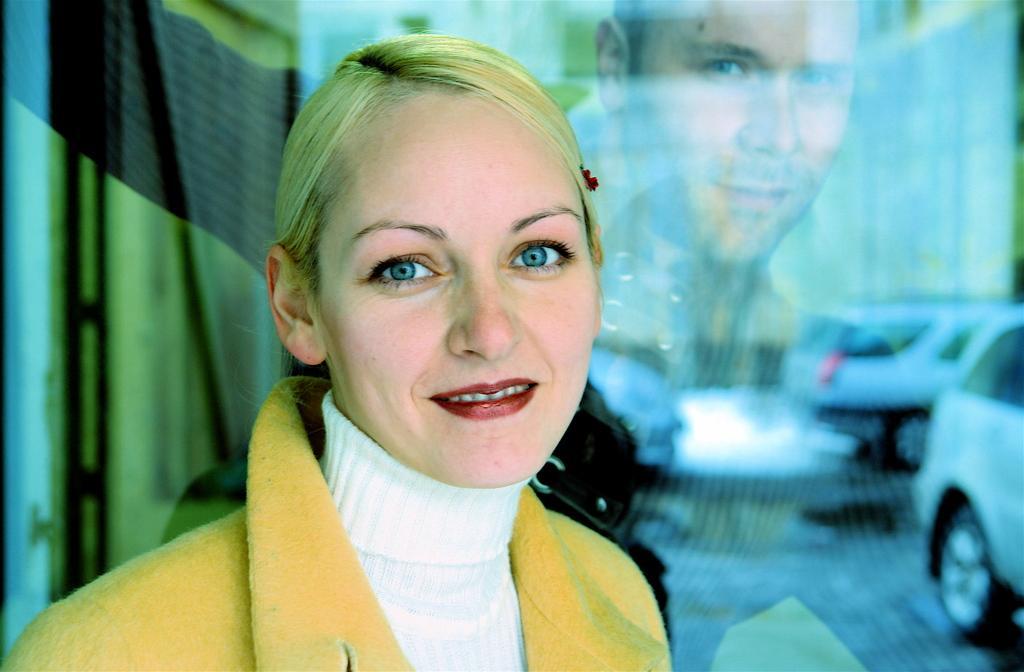How would you summarize this image in a sentence or two? In this image there is a woman towards the bottom of the image, there is a man towards the top of the image, there is a glass behind the woman, there is an object towards the left of the image, there are cars on the ground, the background of the image is blurred. 